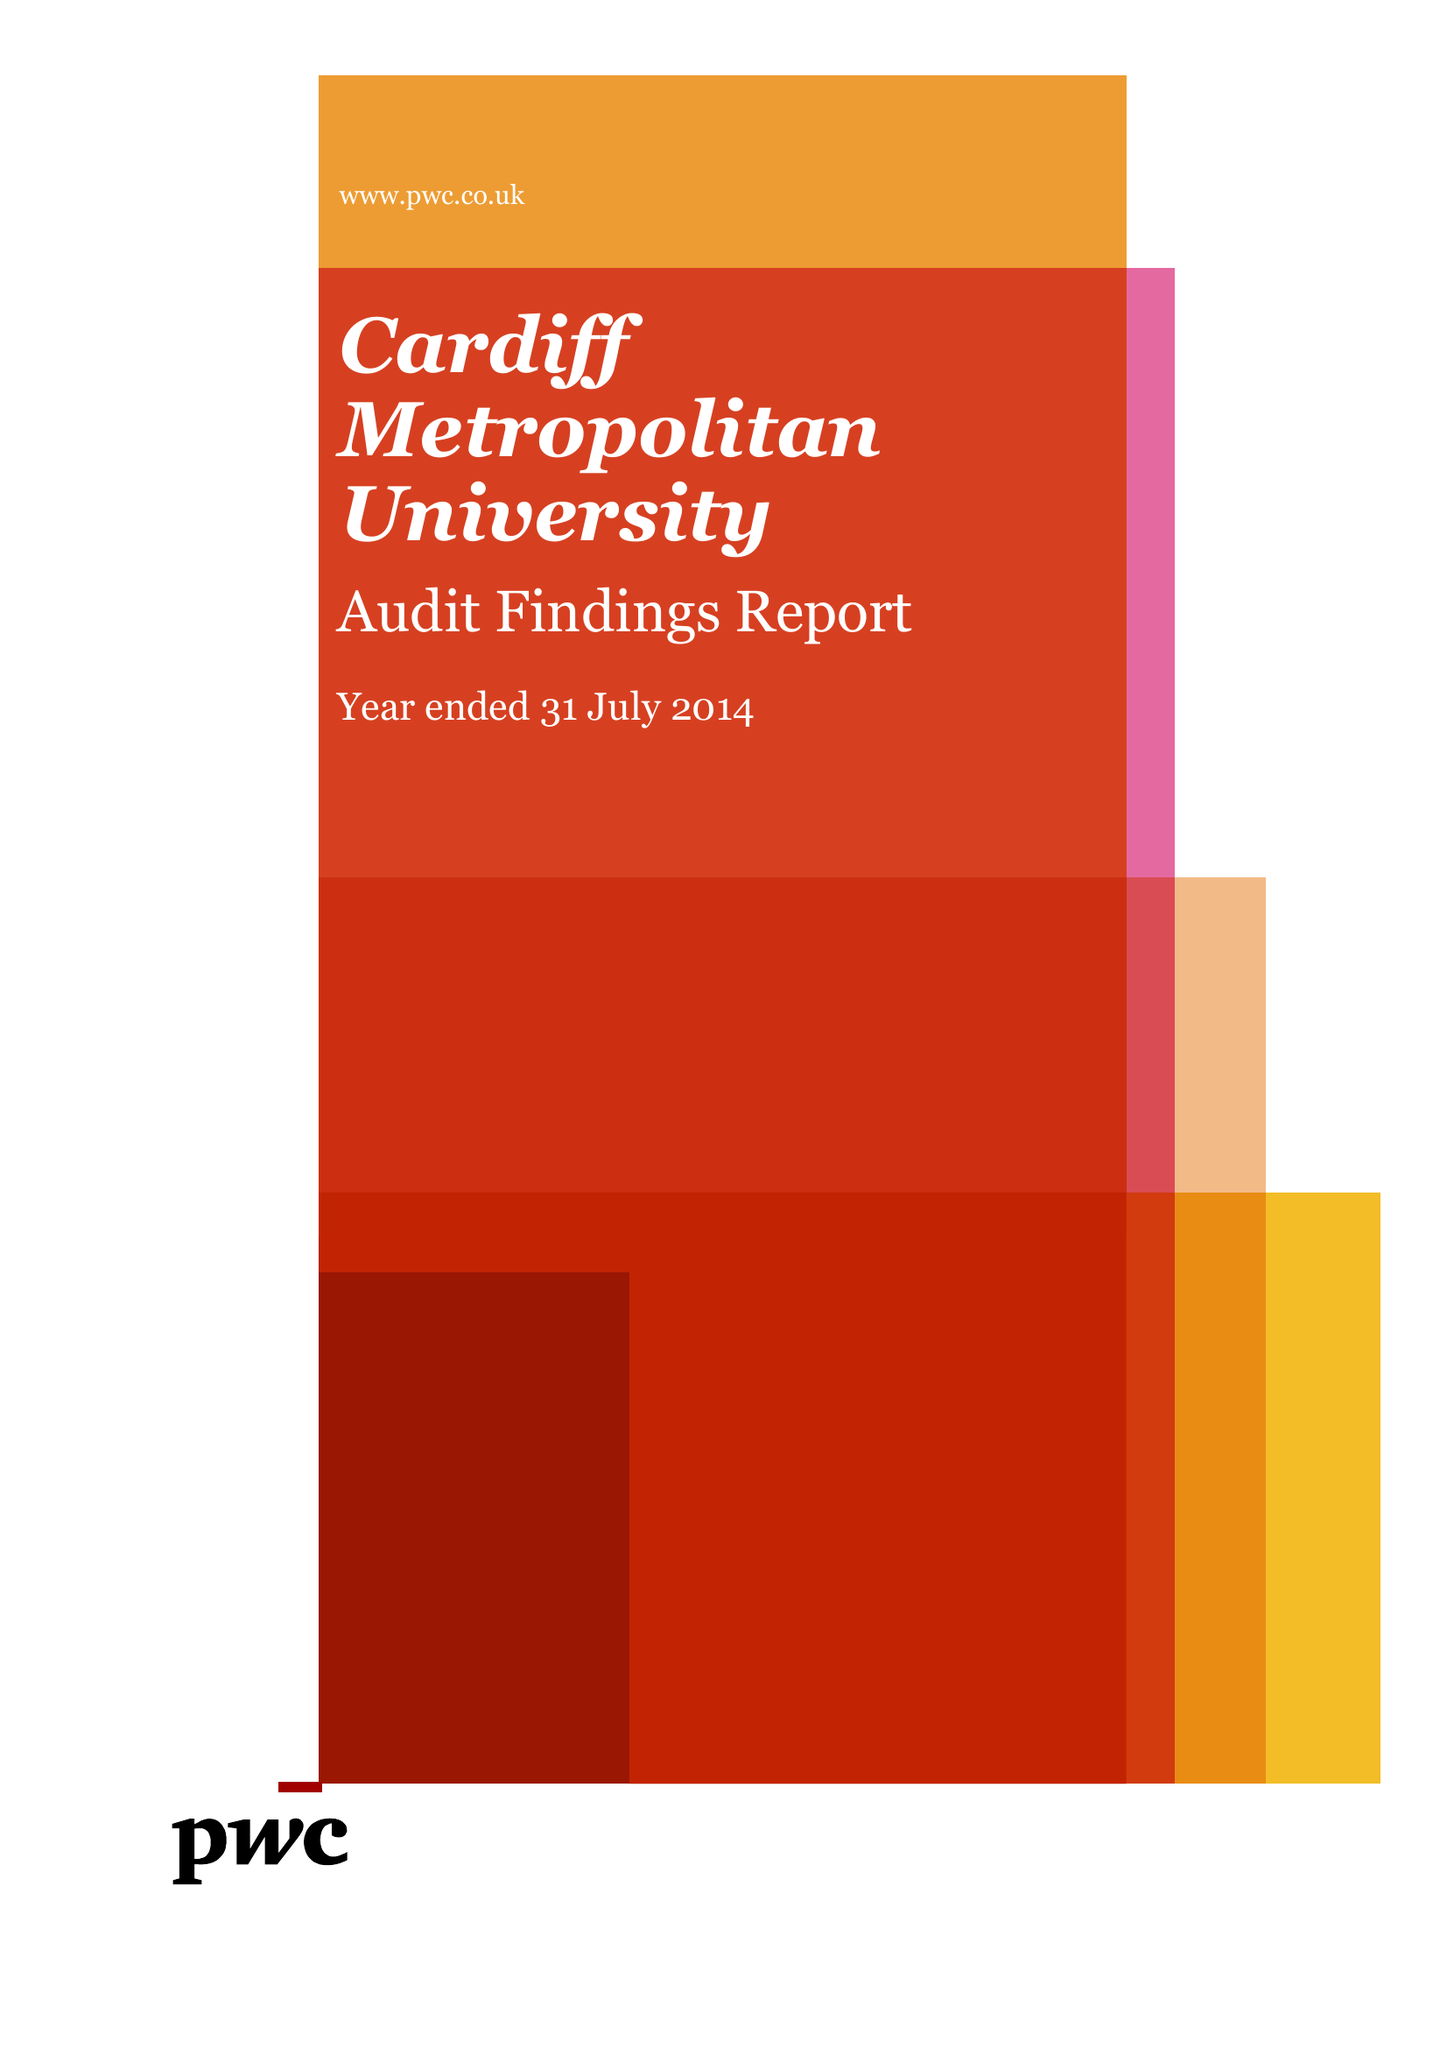What is the value for the address__postcode?
Answer the question using a single word or phrase. CF5 2YB 